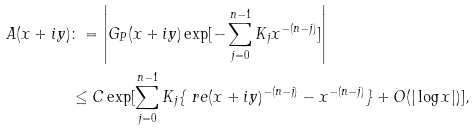<formula> <loc_0><loc_0><loc_500><loc_500>A ( x + i y ) & \colon = \left | G _ { P } ( x + i y ) \exp [ - \sum _ { j = 0 } ^ { n - 1 } K _ { j } x ^ { - ( n - j ) } ] \right | \\ & \leq C \exp [ \sum _ { j = 0 } ^ { n - 1 } K _ { j } \{ \ r e ( x + i y ) ^ { - ( n - j ) } - x ^ { - ( n - j ) } \} + O ( | \log x | ) ] ,</formula> 